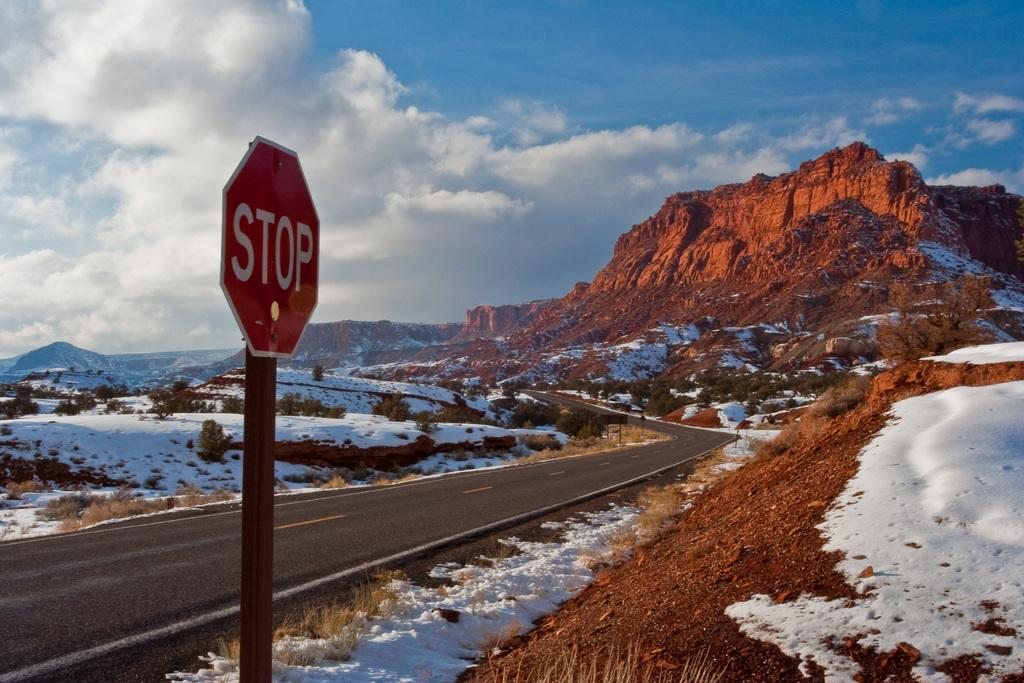<image>
Render a clear and concise summary of the photo. Stop sign on the side of a road that is covered with snow 